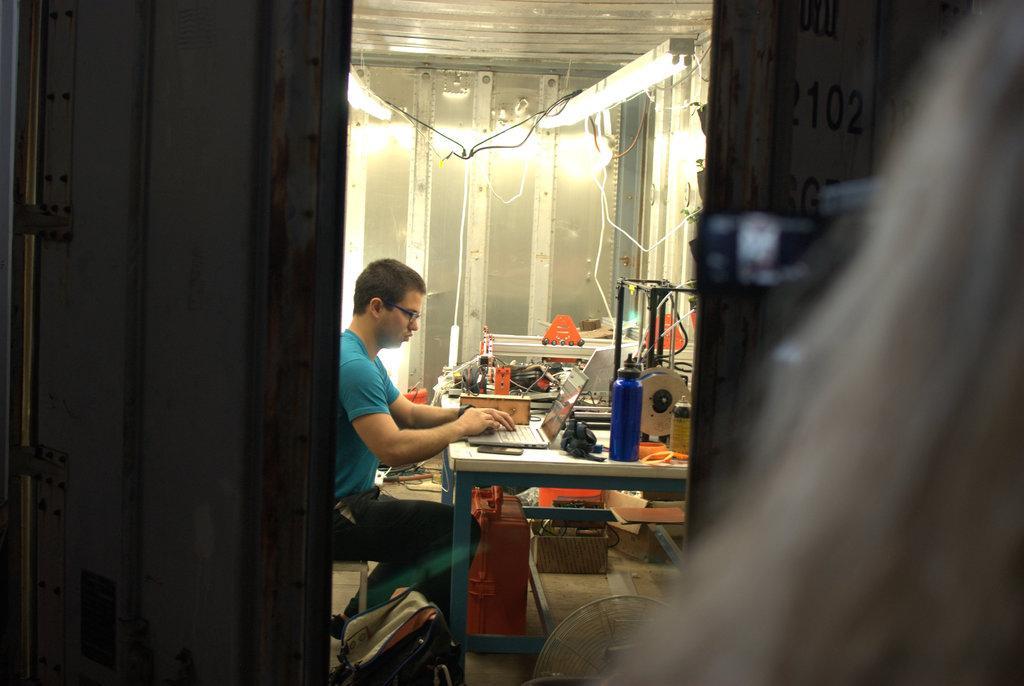In one or two sentences, can you explain what this image depicts? In this image there is a person sitting in a chair is working on a laptop in front of him on the table, on the table there is some other stuff, beneath the table there is some other stuff, at the top of the image there are lights. 